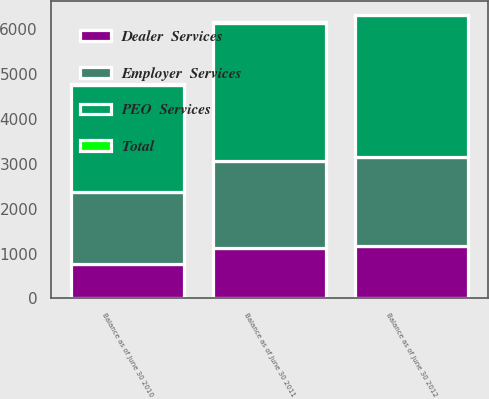Convert chart. <chart><loc_0><loc_0><loc_500><loc_500><stacked_bar_chart><ecel><fcel>Balance as of June 30 2010<fcel>Balance as of June 30 2011<fcel>Balance as of June 30 2012<nl><fcel>Employer  Services<fcel>1611.3<fcel>1935<fcel>1980.9<nl><fcel>Total<fcel>4.8<fcel>4.8<fcel>4.8<nl><fcel>Dealer  Services<fcel>767.2<fcel>1133.8<fcel>1169.6<nl><fcel>PEO  Services<fcel>2383.3<fcel>3073.6<fcel>3155.3<nl></chart> 